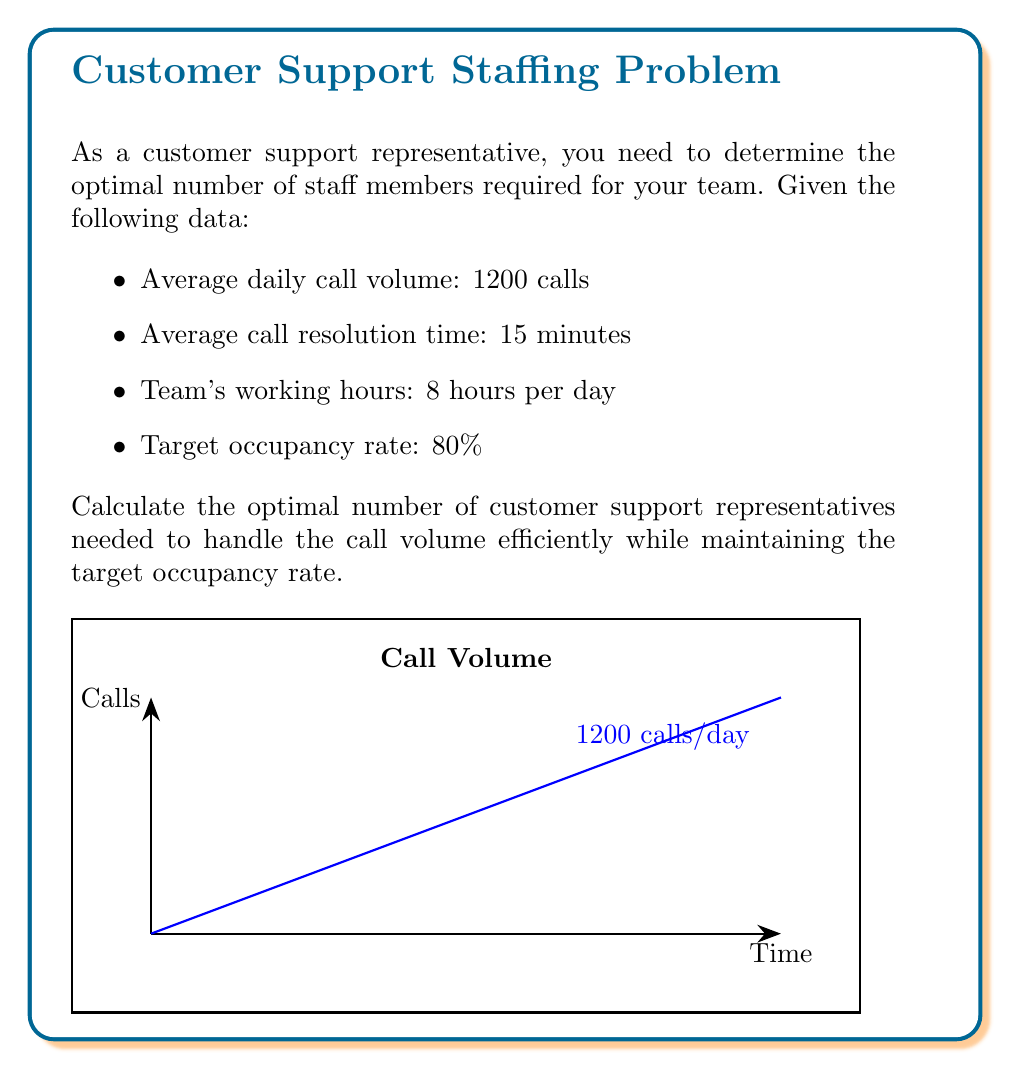Could you help me with this problem? Let's approach this problem step-by-step:

1. Calculate the total call handling time per day:
   $$\text{Total call time} = \text{Number of calls} \times \text{Average resolution time}$$
   $$\text{Total call time} = 1200 \times 15 \text{ minutes} = 18000 \text{ minutes}$$

2. Convert the total call time to hours:
   $$\text{Total call time in hours} = \frac{18000 \text{ minutes}}{60 \text{ minutes/hour}} = 300 \text{ hours}$$

3. Calculate the number of work hours available per representative:
   $$\text{Work hours per rep} = 8 \text{ hours}$$

4. Calculate the raw number of representatives needed:
   $$\text{Raw number of reps} = \frac{\text{Total call time in hours}}{\text{Work hours per rep}}$$
   $$\text{Raw number of reps} = \frac{300}{8} = 37.5$$

5. Adjust for the target occupancy rate:
   The occupancy rate is the percentage of time representatives spend on calls. To achieve an 80% occupancy rate, we need to divide the raw number by 0.8:

   $$\text{Optimal number of reps} = \frac{\text{Raw number of reps}}{\text{Target occupancy rate}}$$
   $$\text{Optimal number of reps} = \frac{37.5}{0.8} = 46.875$$

6. Round up to the nearest whole number, as we can't have fractional staff members:
   $$\text{Final optimal number of reps} = \lceil 46.875 \rceil = 47$$

Therefore, the optimal number of customer support representatives needed is 47.
Answer: 47 representatives 